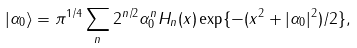<formula> <loc_0><loc_0><loc_500><loc_500>| \alpha _ { 0 } \rangle = \pi ^ { 1 / 4 } \sum _ { n } 2 ^ { n / 2 } \alpha _ { 0 } ^ { n } H _ { n } ( x ) \exp \{ - ( x ^ { 2 } + | \alpha _ { 0 } | ^ { 2 } ) / 2 \} ,</formula> 